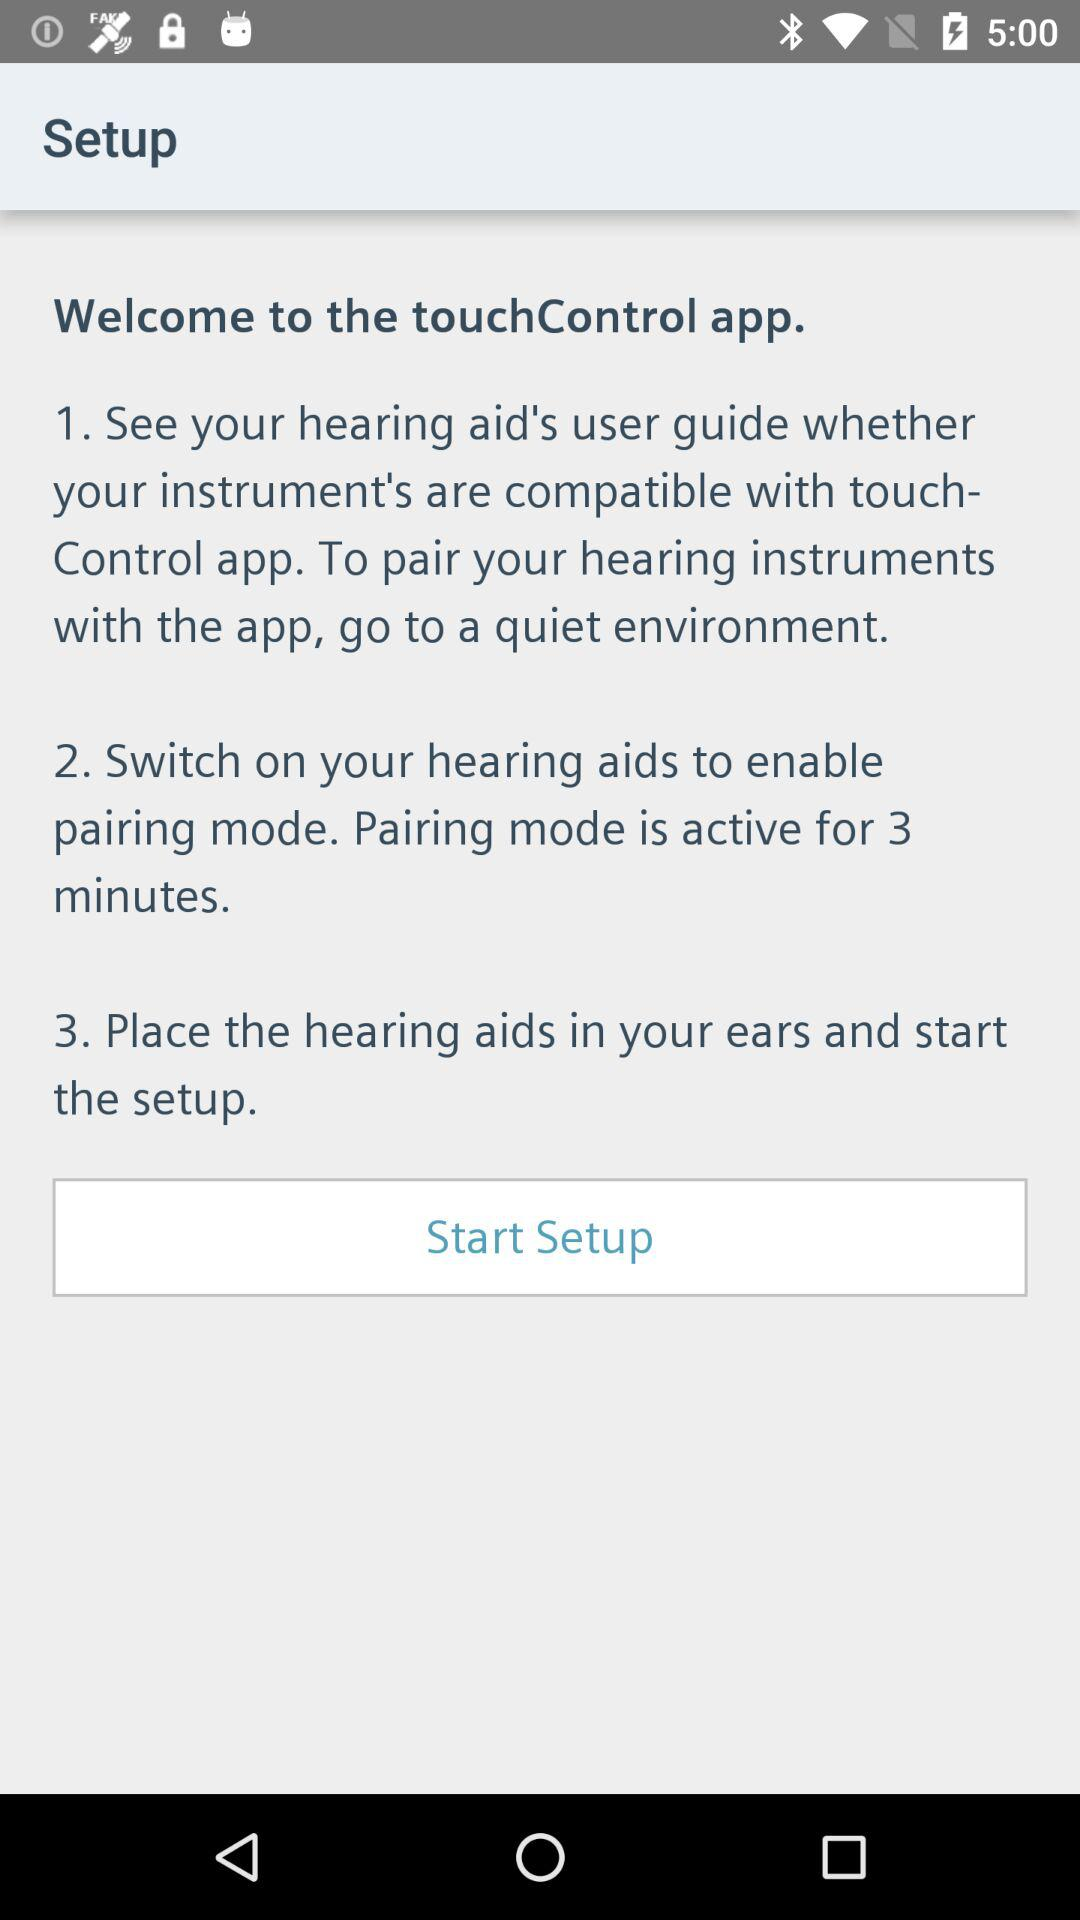How many steps are there in the setup process?
Answer the question using a single word or phrase. 3 